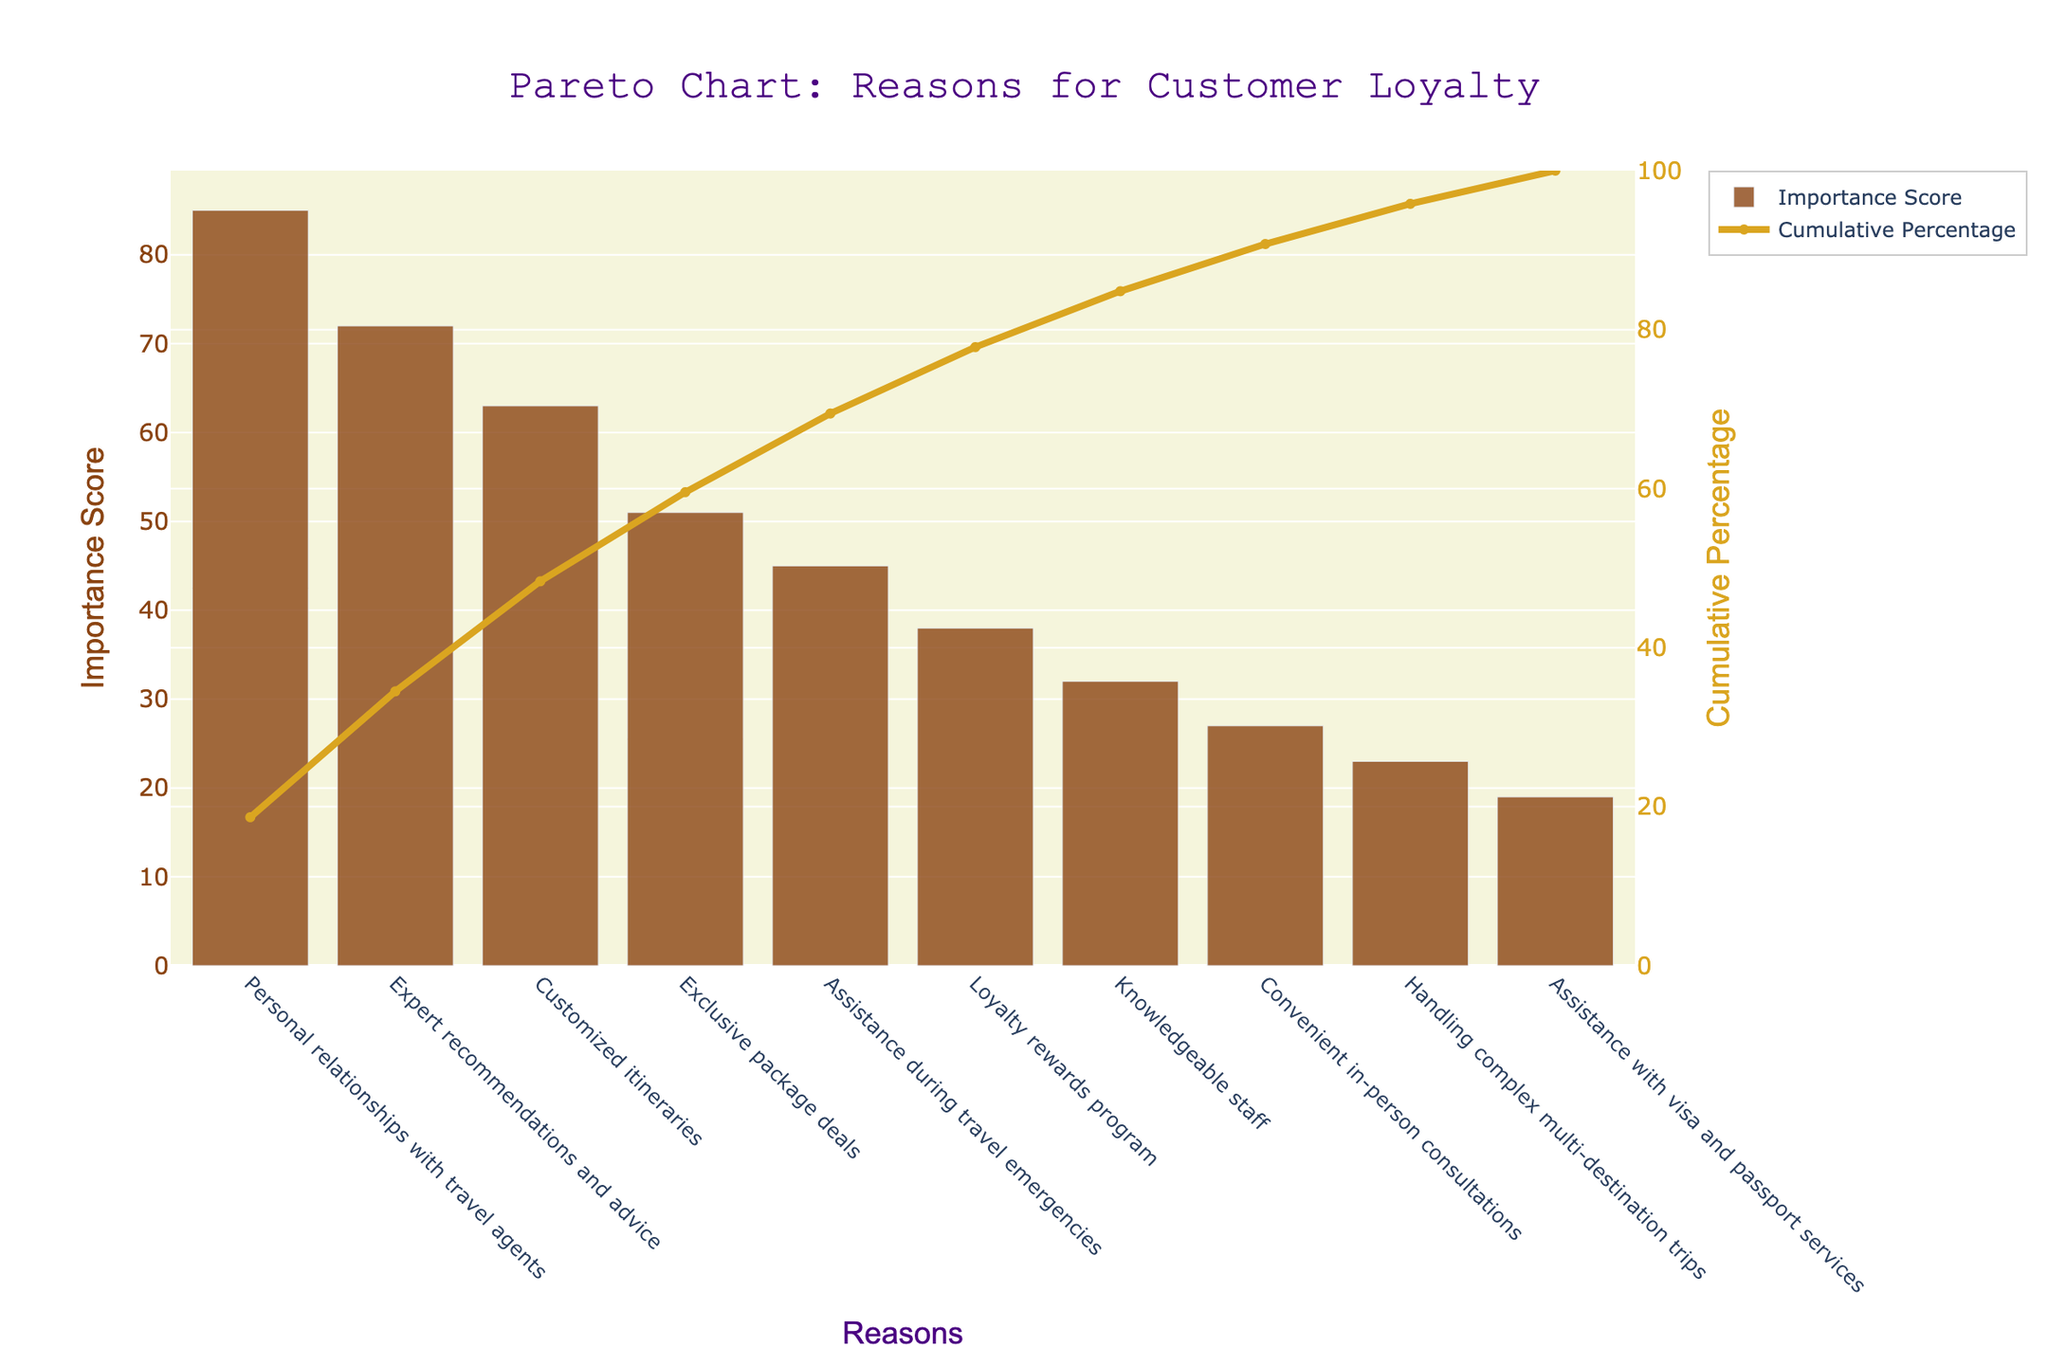How many reasons for customer loyalty are shown in the chart? Count the data points listed on the x-axis of the chart. There are 10 distinct reasons.
Answer: 10 Which reason has the highest importance score? Identify the tallest bar on the chart, which represents the reason with the highest importance score. The tallest bar corresponds to "Personal relationships with travel agents."
Answer: Personal relationships with travel agents What is the cumulative percentage reached by the top 3 reasons? Look at the line representing cumulative percentage and sum the y-values of the top 3 reasons. The top 3 reasons are "Personal relationships with travel agents" (85), "Expert recommendations and advice" (72), and "Customized itineraries" (63). Cumulative percentages are approximately 33%, 61%, and 84%. Adding them, the cumulative percentage reaches about 84%.
Answer: 84% Which reason ranks fifth in importance? Check the height of bars in descending order and identify the fifth. The fifth reason is "Assistance during travel emergencies."
Answer: Assistance during travel emergencies Compare the importance scores between "Loyalty rewards program" and "Handling complex multi-destination trips." Which one is higher? Look at the bars corresponding to these two reasons. "Loyalty rewards program" has a score of 38, while "Handling complex multi-destination trips" has a score of 23. Thus, the "Loyalty rewards program" is higher.
Answer: Loyalty rewards program What is the cumulative percentage after the seventh reason? Identify the cumulative percentage after the seventh reason. The seventh reason is "Knowledgeable staff" (32). The cumulative percentage after the seventh reason is around 95%.
Answer: 95% Which reasons have importance scores lower than 30? Look at the y-axis and identify bars with heights less than 30. These reasons are "Convenient in-person consultations" (27), "Handling complex multi-destination trips" (23), and "Assistance with visa and passport services" (19).
Answer: Convenient in-person consultations, Handling complex multi-destination trips, Assistance with visa and passport services How much higher is the importance score for "Personal relationships with travel agents" compared to "Assistance during travel emergencies"? Subtract the importance score of "Assistance during travel emergencies" (45) from "Personal relationships with travel agents" (85). The difference is 40.
Answer: 40 What percentage of total importance is captured by "Expert recommendations and advice" alone? Identify the importance score of "Expert recommendations and advice" (72), divide by the total sum of scores (455), and then multiply by 100 to get the percentage. That is (72/455) * 100, approximately 15.8%.
Answer: 15.8% Which reason contributes the least to customer loyalty according to the chart? Identify the shortest bar, which represents the least important reason. The shortest bar corresponds to "Assistance with visa and passport services" with a score of 19.
Answer: Assistance with visa and passport services 